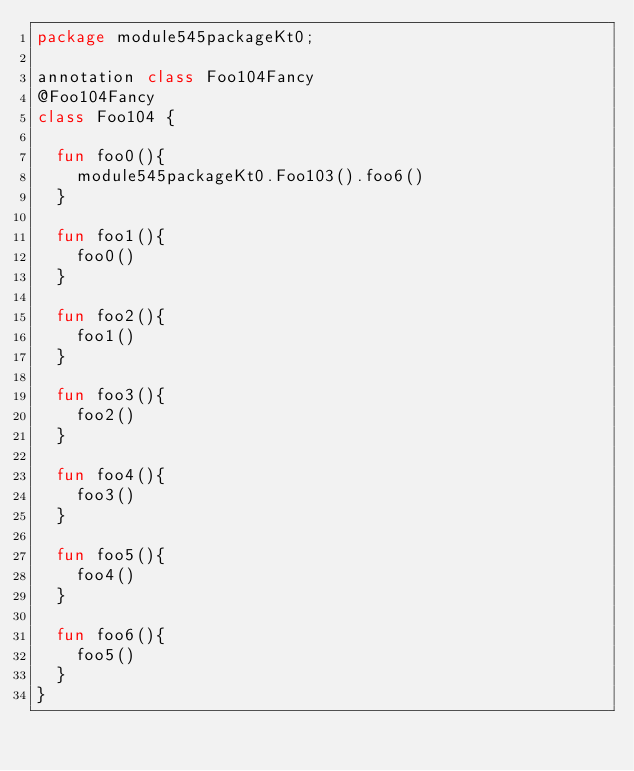Convert code to text. <code><loc_0><loc_0><loc_500><loc_500><_Kotlin_>package module545packageKt0;

annotation class Foo104Fancy
@Foo104Fancy
class Foo104 {

  fun foo0(){
    module545packageKt0.Foo103().foo6()
  }

  fun foo1(){
    foo0()
  }

  fun foo2(){
    foo1()
  }

  fun foo3(){
    foo2()
  }

  fun foo4(){
    foo3()
  }

  fun foo5(){
    foo4()
  }

  fun foo6(){
    foo5()
  }
}</code> 